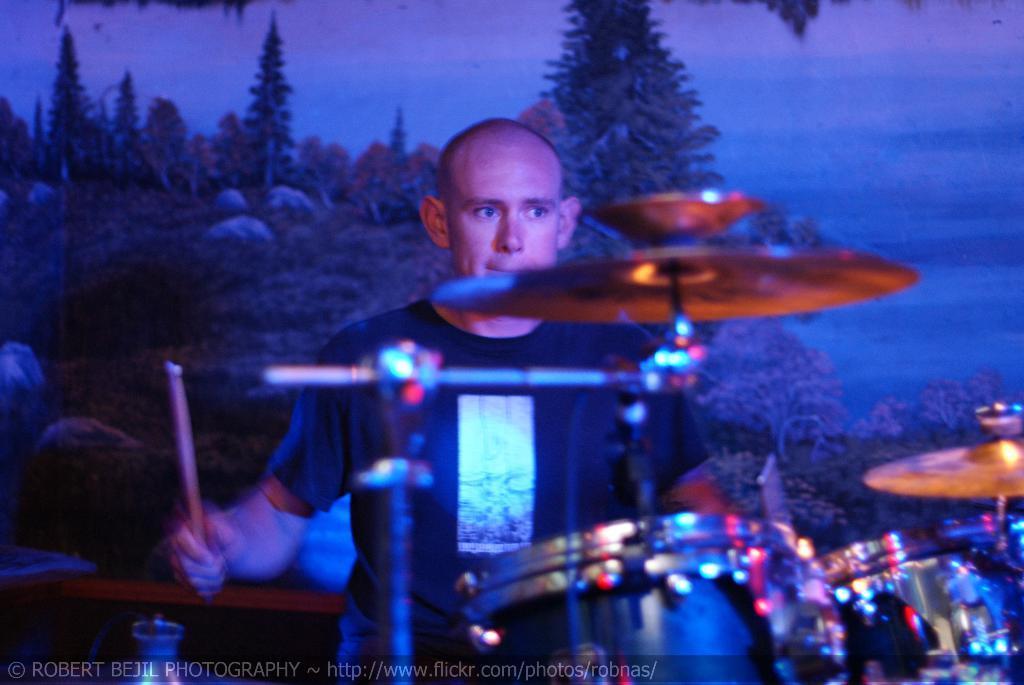Could you give a brief overview of what you see in this image? In this picture we can see a man is holding the drumsticks and in front of the man there are drums and cymbals. Behind the man there is a board. On the image there is a watermark. 